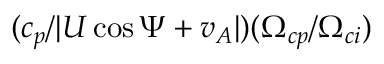<formula> <loc_0><loc_0><loc_500><loc_500>( c _ { p } / | U \cos \Psi + v _ { A } | ) ( \Omega _ { c p } / \Omega _ { c i } )</formula> 